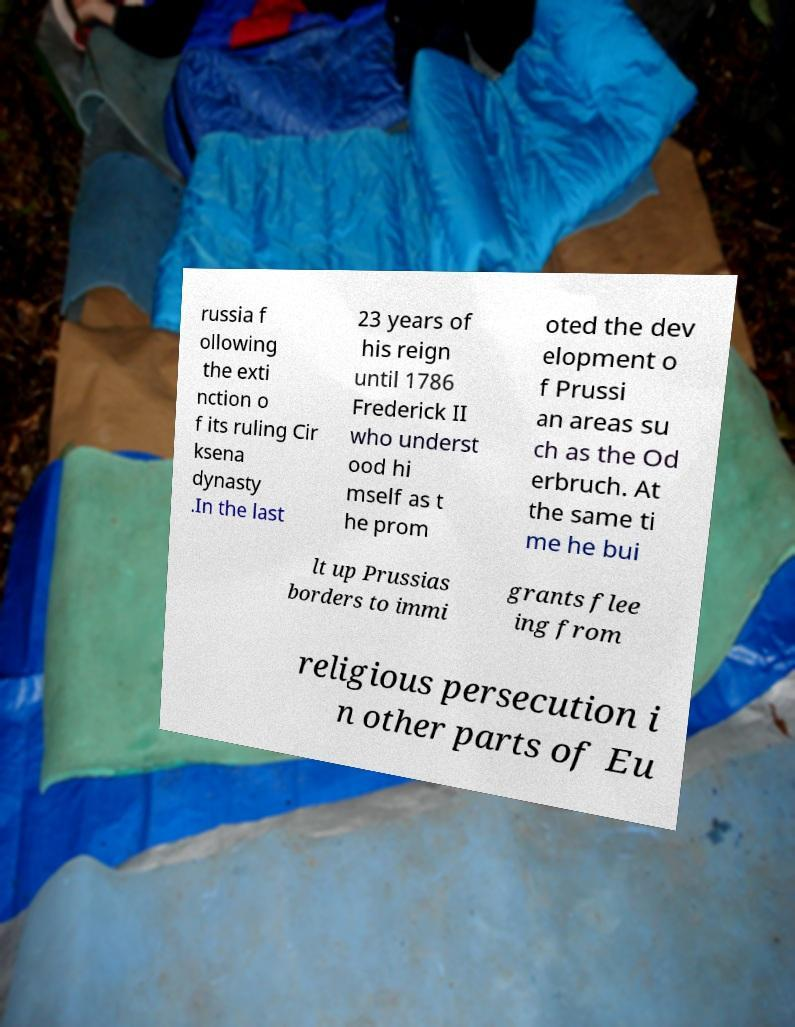Can you accurately transcribe the text from the provided image for me? russia f ollowing the exti nction o f its ruling Cir ksena dynasty .In the last 23 years of his reign until 1786 Frederick II who underst ood hi mself as t he prom oted the dev elopment o f Prussi an areas su ch as the Od erbruch. At the same ti me he bui lt up Prussias borders to immi grants flee ing from religious persecution i n other parts of Eu 